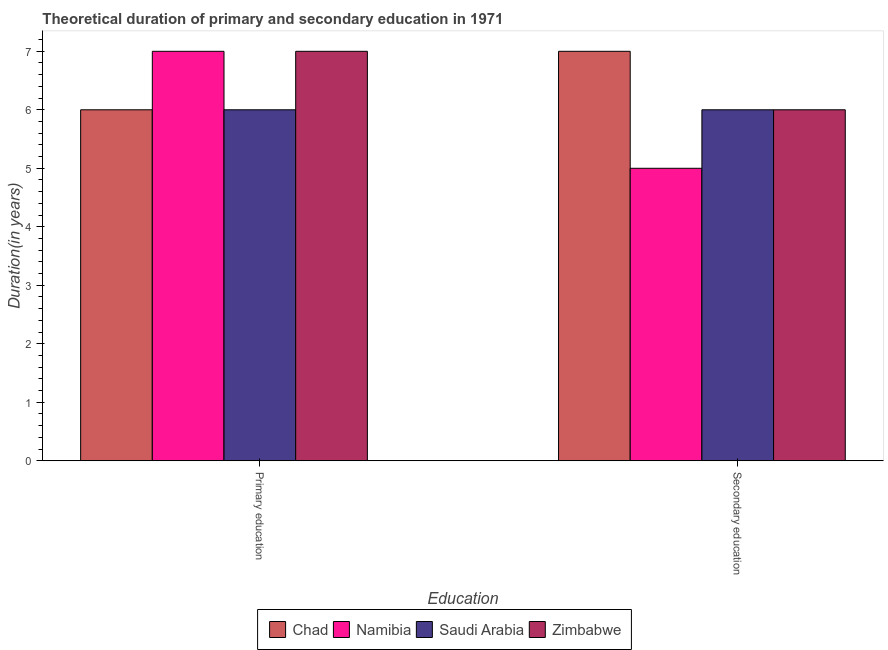How many different coloured bars are there?
Provide a short and direct response. 4. How many groups of bars are there?
Keep it short and to the point. 2. Are the number of bars on each tick of the X-axis equal?
Offer a terse response. Yes. How many bars are there on the 2nd tick from the left?
Your answer should be very brief. 4. What is the label of the 2nd group of bars from the left?
Offer a terse response. Secondary education. What is the duration of primary education in Chad?
Your answer should be very brief. 6. Across all countries, what is the maximum duration of primary education?
Your answer should be compact. 7. Across all countries, what is the minimum duration of secondary education?
Keep it short and to the point. 5. In which country was the duration of primary education maximum?
Your answer should be compact. Namibia. In which country was the duration of primary education minimum?
Your answer should be compact. Chad. What is the total duration of secondary education in the graph?
Make the answer very short. 24. What is the difference between the duration of secondary education in Saudi Arabia and that in Chad?
Provide a succinct answer. -1. What is the difference between the duration of secondary education in Saudi Arabia and the duration of primary education in Zimbabwe?
Give a very brief answer. -1. What is the average duration of primary education per country?
Make the answer very short. 6.5. What is the difference between the duration of secondary education and duration of primary education in Chad?
Provide a succinct answer. 1. What is the ratio of the duration of primary education in Zimbabwe to that in Chad?
Provide a succinct answer. 1.17. Is the duration of secondary education in Namibia less than that in Chad?
Provide a succinct answer. Yes. What does the 1st bar from the left in Secondary education represents?
Your answer should be very brief. Chad. What does the 3rd bar from the right in Primary education represents?
Offer a very short reply. Namibia. Are all the bars in the graph horizontal?
Offer a terse response. No. Are the values on the major ticks of Y-axis written in scientific E-notation?
Your answer should be compact. No. Does the graph contain grids?
Provide a succinct answer. No. Where does the legend appear in the graph?
Keep it short and to the point. Bottom center. How many legend labels are there?
Ensure brevity in your answer.  4. What is the title of the graph?
Make the answer very short. Theoretical duration of primary and secondary education in 1971. What is the label or title of the X-axis?
Make the answer very short. Education. What is the label or title of the Y-axis?
Ensure brevity in your answer.  Duration(in years). What is the Duration(in years) in Saudi Arabia in Primary education?
Offer a terse response. 6. What is the Duration(in years) of Zimbabwe in Primary education?
Your answer should be compact. 7. What is the Duration(in years) of Chad in Secondary education?
Keep it short and to the point. 7. What is the Duration(in years) in Namibia in Secondary education?
Your response must be concise. 5. What is the Duration(in years) of Saudi Arabia in Secondary education?
Make the answer very short. 6. What is the Duration(in years) of Zimbabwe in Secondary education?
Give a very brief answer. 6. Across all Education, what is the maximum Duration(in years) of Chad?
Your answer should be compact. 7. Across all Education, what is the maximum Duration(in years) of Namibia?
Ensure brevity in your answer.  7. Across all Education, what is the maximum Duration(in years) of Zimbabwe?
Your answer should be compact. 7. Across all Education, what is the minimum Duration(in years) of Chad?
Make the answer very short. 6. Across all Education, what is the minimum Duration(in years) in Saudi Arabia?
Ensure brevity in your answer.  6. Across all Education, what is the minimum Duration(in years) of Zimbabwe?
Offer a terse response. 6. What is the total Duration(in years) of Chad in the graph?
Ensure brevity in your answer.  13. What is the total Duration(in years) of Zimbabwe in the graph?
Offer a terse response. 13. What is the difference between the Duration(in years) in Chad in Primary education and that in Secondary education?
Your answer should be compact. -1. What is the difference between the Duration(in years) of Namibia in Primary education and that in Secondary education?
Make the answer very short. 2. What is the difference between the Duration(in years) in Chad in Primary education and the Duration(in years) in Saudi Arabia in Secondary education?
Provide a short and direct response. 0. What is the difference between the Duration(in years) in Chad in Primary education and the Duration(in years) in Zimbabwe in Secondary education?
Keep it short and to the point. 0. What is the difference between the Duration(in years) in Namibia in Primary education and the Duration(in years) in Zimbabwe in Secondary education?
Your answer should be very brief. 1. What is the average Duration(in years) of Chad per Education?
Offer a very short reply. 6.5. What is the difference between the Duration(in years) of Chad and Duration(in years) of Zimbabwe in Primary education?
Provide a short and direct response. -1. What is the difference between the Duration(in years) in Namibia and Duration(in years) in Saudi Arabia in Primary education?
Provide a short and direct response. 1. What is the difference between the Duration(in years) of Namibia and Duration(in years) of Zimbabwe in Primary education?
Give a very brief answer. 0. What is the difference between the Duration(in years) of Chad and Duration(in years) of Namibia in Secondary education?
Make the answer very short. 2. What is the difference between the Duration(in years) of Chad and Duration(in years) of Saudi Arabia in Secondary education?
Offer a terse response. 1. What is the difference between the Duration(in years) in Namibia and Duration(in years) in Saudi Arabia in Secondary education?
Provide a short and direct response. -1. What is the difference between the Duration(in years) in Saudi Arabia and Duration(in years) in Zimbabwe in Secondary education?
Ensure brevity in your answer.  0. What is the ratio of the Duration(in years) in Chad in Primary education to that in Secondary education?
Provide a succinct answer. 0.86. What is the ratio of the Duration(in years) of Namibia in Primary education to that in Secondary education?
Give a very brief answer. 1.4. What is the ratio of the Duration(in years) in Zimbabwe in Primary education to that in Secondary education?
Offer a terse response. 1.17. What is the difference between the highest and the second highest Duration(in years) of Namibia?
Provide a succinct answer. 2. What is the difference between the highest and the lowest Duration(in years) in Chad?
Your answer should be compact. 1. What is the difference between the highest and the lowest Duration(in years) of Namibia?
Ensure brevity in your answer.  2. What is the difference between the highest and the lowest Duration(in years) of Saudi Arabia?
Give a very brief answer. 0. 